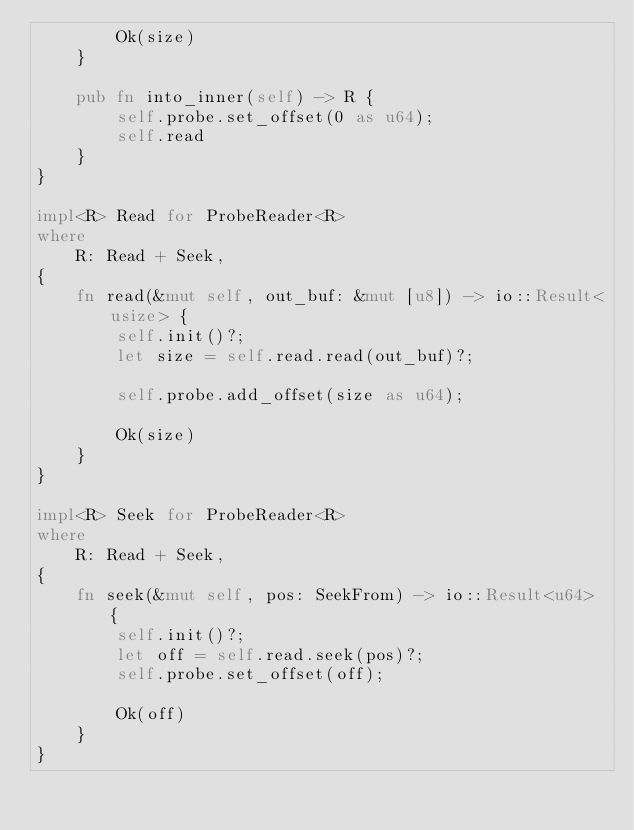Convert code to text. <code><loc_0><loc_0><loc_500><loc_500><_Rust_>        Ok(size)
    }

    pub fn into_inner(self) -> R {
        self.probe.set_offset(0 as u64);
        self.read
    }
}

impl<R> Read for ProbeReader<R>
where
    R: Read + Seek,
{
    fn read(&mut self, out_buf: &mut [u8]) -> io::Result<usize> {
        self.init()?;
        let size = self.read.read(out_buf)?;

        self.probe.add_offset(size as u64);

        Ok(size)
    }
}

impl<R> Seek for ProbeReader<R>
where
    R: Read + Seek,
{
    fn seek(&mut self, pos: SeekFrom) -> io::Result<u64> {
        self.init()?;
        let off = self.read.seek(pos)?;
        self.probe.set_offset(off);

        Ok(off)
    }
}
</code> 